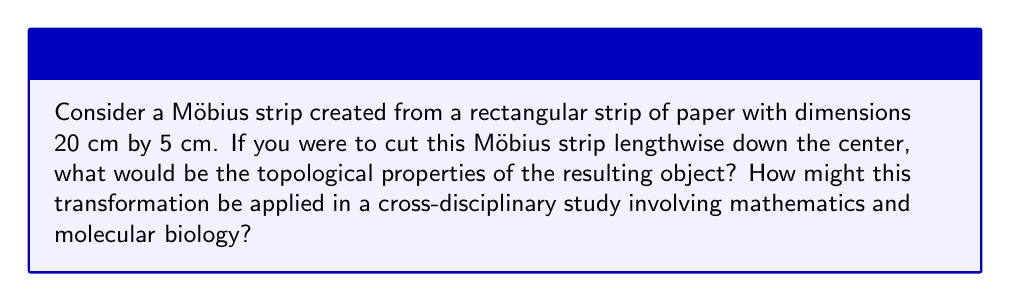Help me with this question. To answer this question, let's break it down into steps:

1. Understand the initial Möbius strip:
   A Möbius strip is a non-orientable surface with only one side and one edge. It's created by taking a rectangular strip and giving it a half-twist before joining the ends.

2. Cutting the Möbius strip:
   When you cut a Möbius strip lengthwise down the center, you don't get two separate strips as you might expect. Instead, you get one long strip with two full twists.

3. Topological properties of the resulting object:
   - The resulting strip is orientable (unlike the original Möbius strip).
   - It has two sides (compared to the one side of the original Möbius strip).
   - It has two edges (compared to the one edge of the original Möbius strip).
   - The length of the new strip is double that of the original Möbius strip.
   - The width of the new strip is half that of the original Möbius strip.

4. Calculating dimensions:
   - Original strip: 20 cm x 5 cm
   - New strip: 40 cm x 2.5 cm (twice the length, half the width)

5. Cross-disciplinary application in molecular biology:
   The transformation of the Möbius strip through cutting can be analogous to certain molecular processes in biology, such as:
   - DNA replication: The process of unwinding and copying DNA strands can be visualized using the Möbius strip model.
   - Protein folding: The complex three-dimensional structures of proteins can be studied using topological models similar to the Möbius strip transformation.

6. Mathematical representation:
   The Möbius strip can be parametrized as:

   $$
   x(u,v) = (1 + \frac{v}{2}\cos(\frac{u}{2}))\cos(u) \\
   y(u,v) = (1 + \frac{v}{2}\cos(\frac{u}{2}))\sin(u) \\
   z(u,v) = \frac{v}{2}\sin(\frac{u}{2})
   $$

   Where $0 \leq u < 2\pi$ and $-1 \leq v \leq 1$.

This transformation demonstrates how a simple topological change can result in significant alterations to an object's properties, providing a powerful tool for understanding complex systems in both mathematics and biology.
Answer: The resulting object from cutting the Möbius strip lengthwise is a single long strip with two full twists, dimensions 40 cm x 2.5 cm, that is orientable with two sides and two edges. This transformation can be applied in cross-disciplinary studies to model processes like DNA replication or protein folding in molecular biology, providing a visual and topological framework for understanding complex biological structures and processes. 